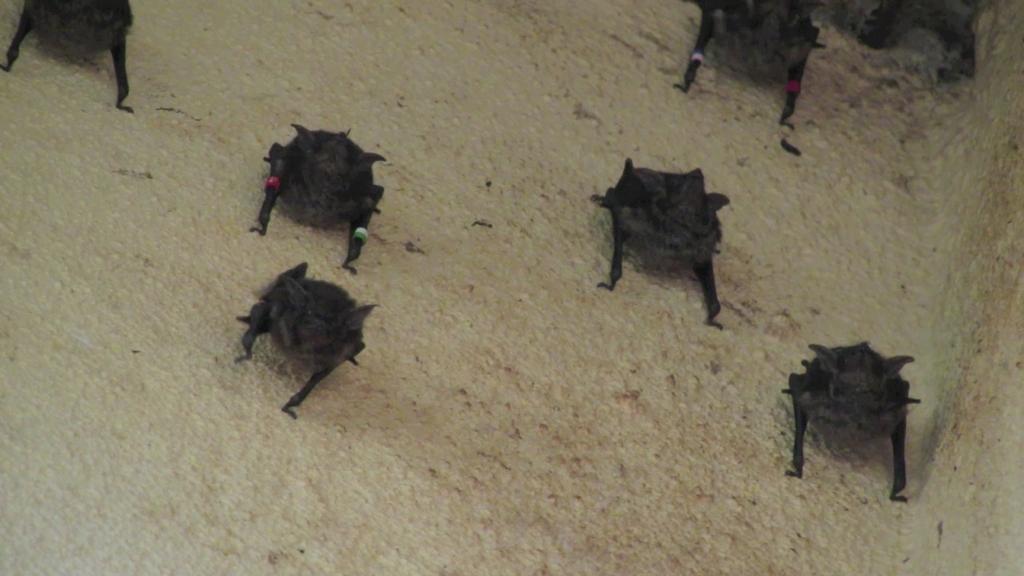Can you describe this image briefly? In this image there are black color insects on the path. 